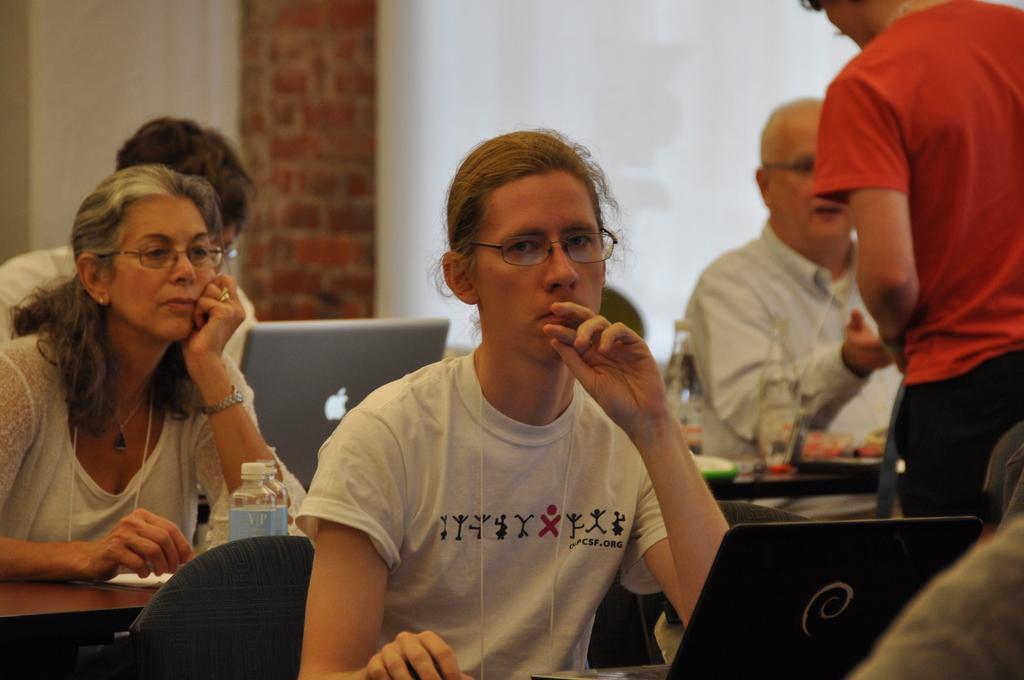Can you describe this image briefly? In this picture we can see a group of people sitting on chairs and in front of them we can see laptops, bottles and a person standing and in the background we can see wall. 